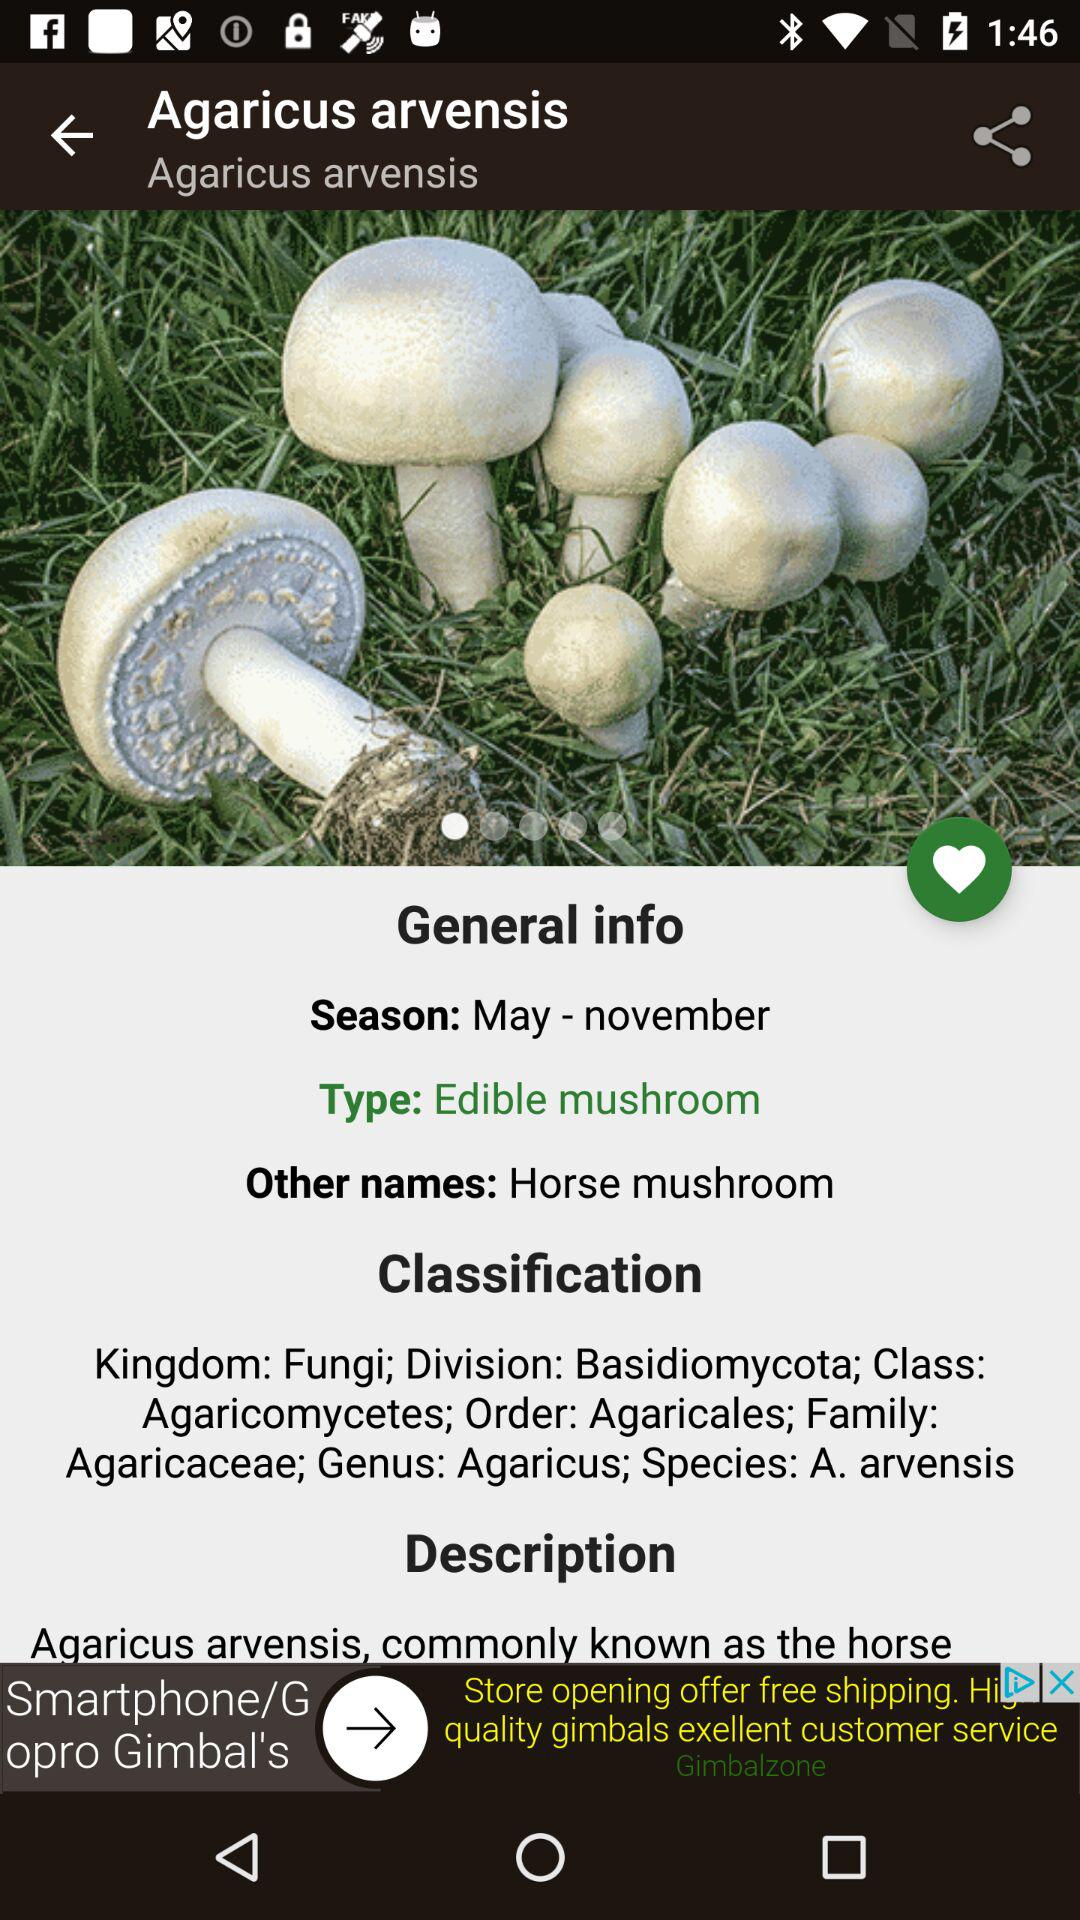What is the season of Agaricus arvensis? The season of the agaricus arensis is May to November. 